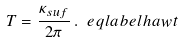<formula> <loc_0><loc_0><loc_500><loc_500>T = \frac { \kappa _ { s u f } } { 2 \pi } \, . \ e q l a b e l { h a w t }</formula> 